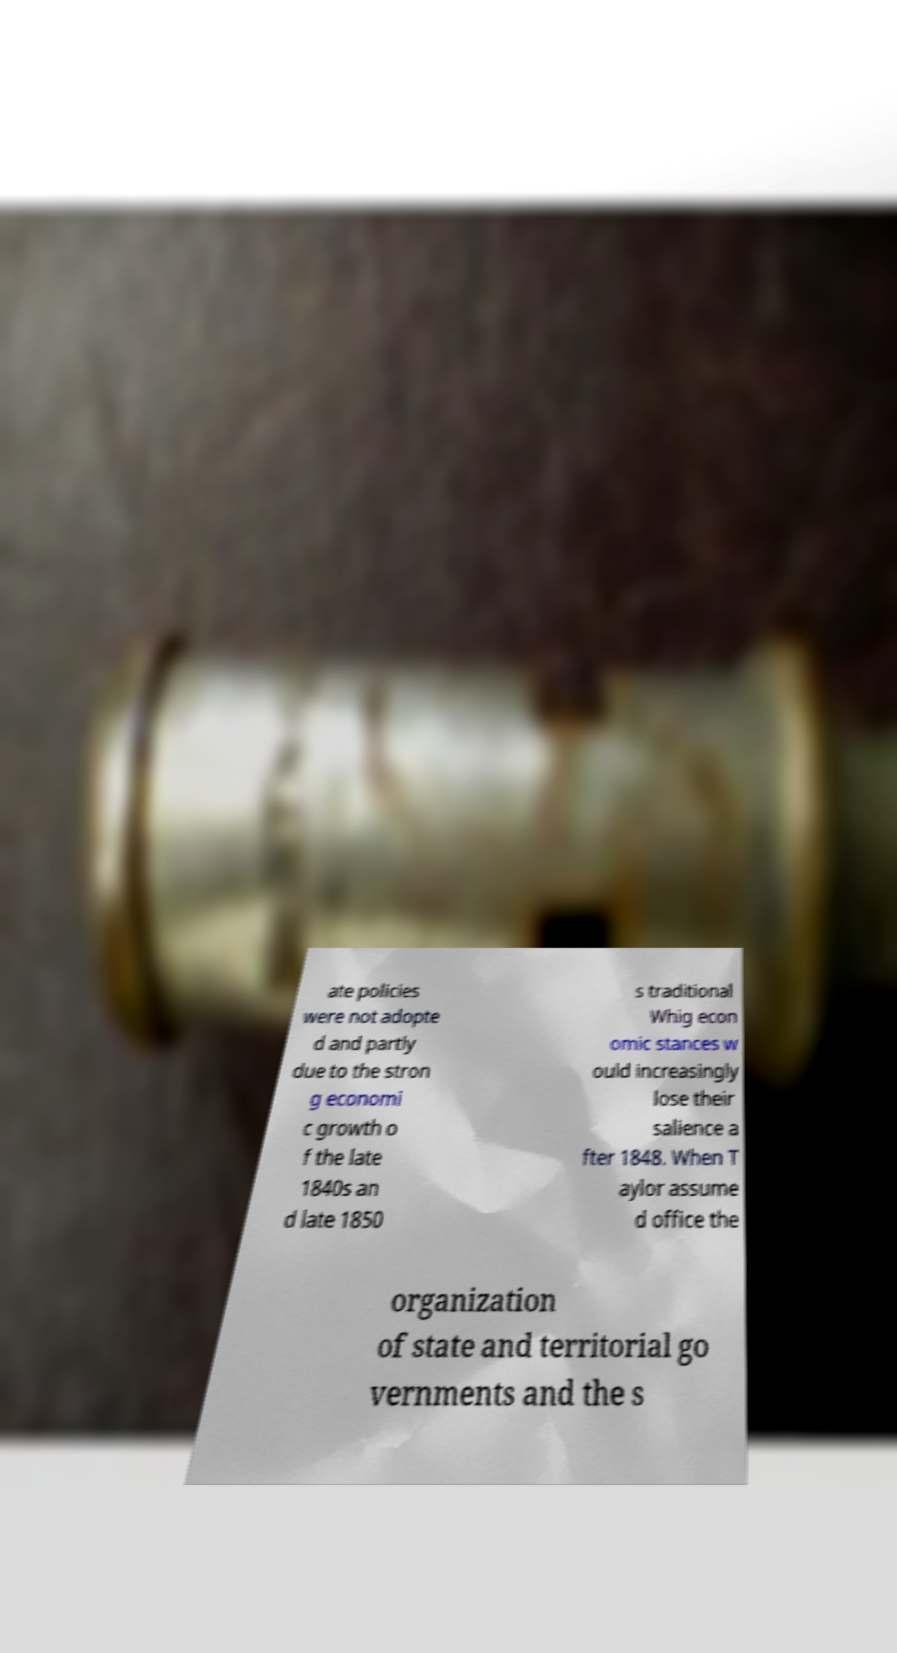Could you extract and type out the text from this image? ate policies were not adopte d and partly due to the stron g economi c growth o f the late 1840s an d late 1850 s traditional Whig econ omic stances w ould increasingly lose their salience a fter 1848. When T aylor assume d office the organization of state and territorial go vernments and the s 